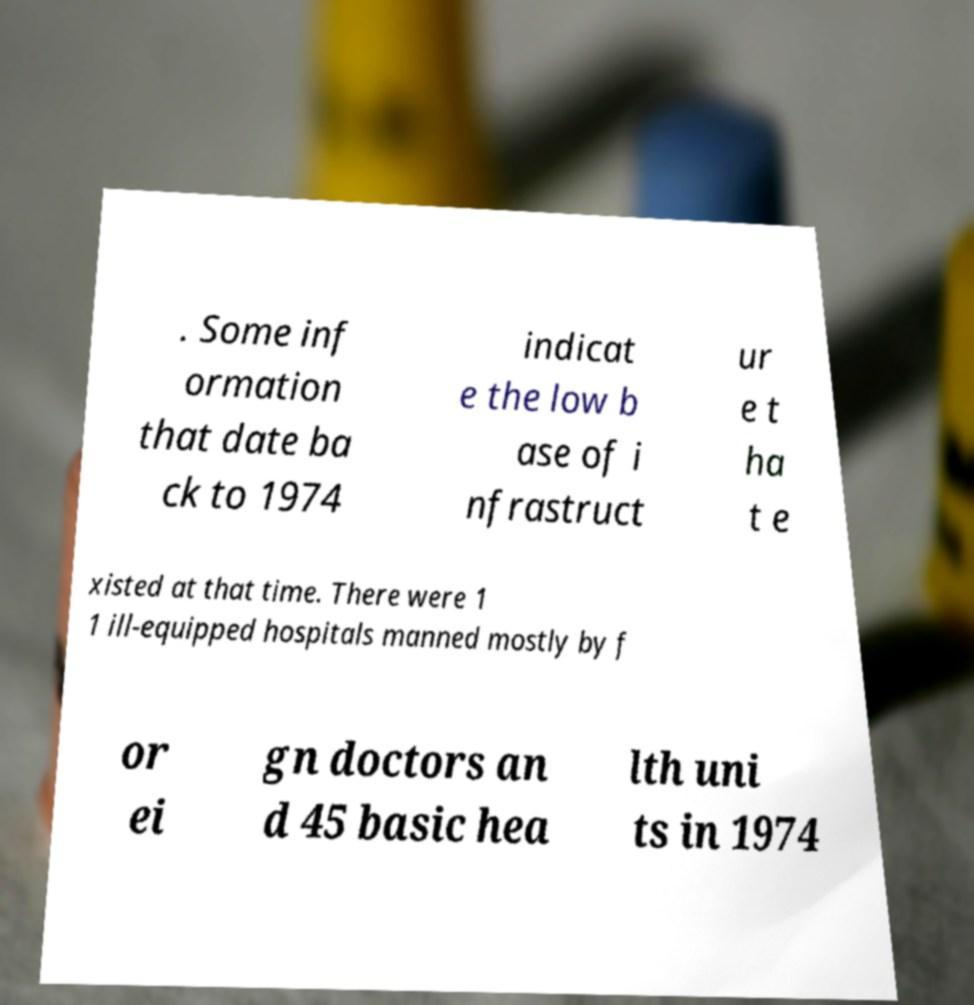For documentation purposes, I need the text within this image transcribed. Could you provide that? . Some inf ormation that date ba ck to 1974 indicat e the low b ase of i nfrastruct ur e t ha t e xisted at that time. There were 1 1 ill-equipped hospitals manned mostly by f or ei gn doctors an d 45 basic hea lth uni ts in 1974 